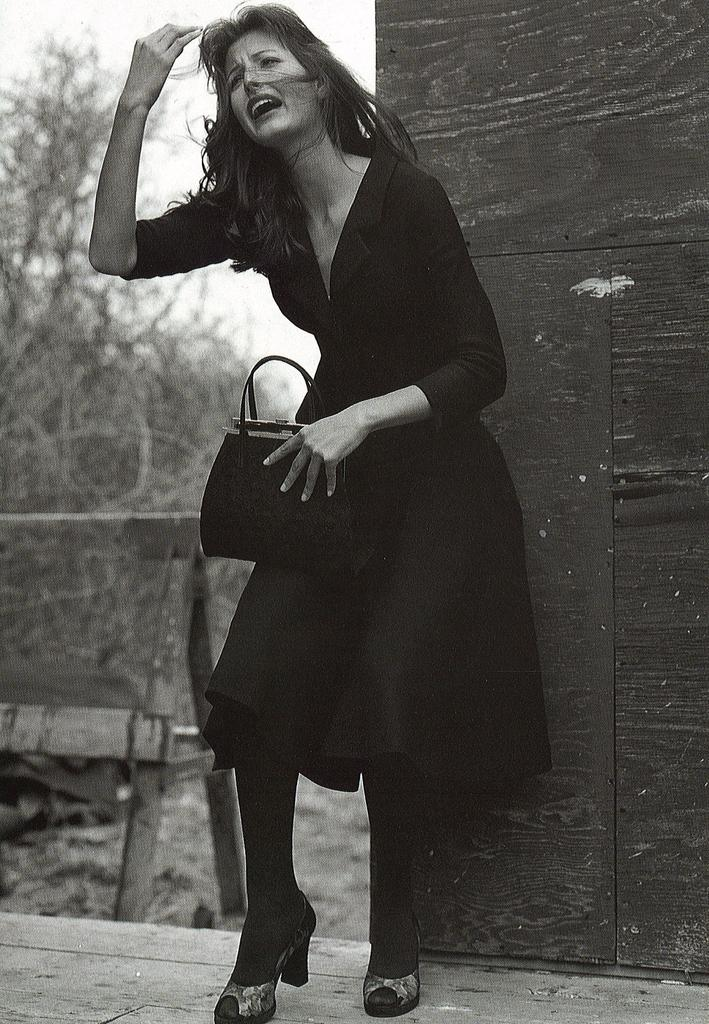Who is present in the image? There is a woman in the image. What is the woman doing in the image? The woman is standing in the image. What is the woman holding in the image? The woman is holding a bag in the image. Where is the woman located in the image? The woman is on a path in the image. What can be seen in the background of the image? There are plants and a wall in the background of the image. What type of board is the woman discussing with her friend in the image? There is no board or friend present in the image; it only features a woman standing on a path with a bag and a background of plants and a wall. 